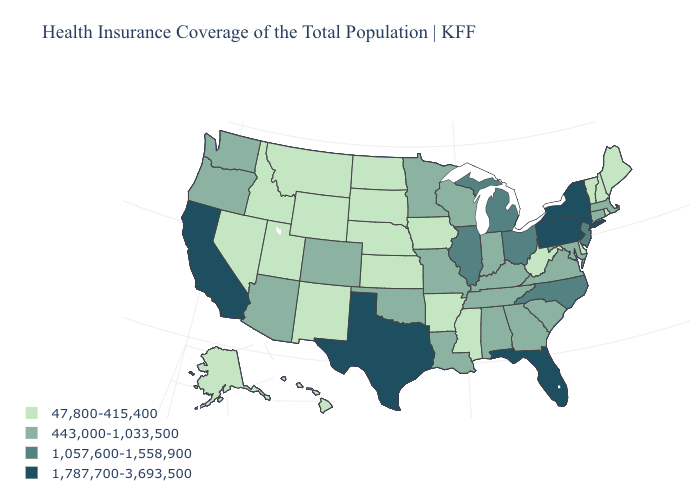Name the states that have a value in the range 443,000-1,033,500?
Short answer required. Alabama, Arizona, Colorado, Connecticut, Georgia, Indiana, Kentucky, Louisiana, Maryland, Massachusetts, Minnesota, Missouri, Oklahoma, Oregon, South Carolina, Tennessee, Virginia, Washington, Wisconsin. Name the states that have a value in the range 1,057,600-1,558,900?
Keep it brief. Illinois, Michigan, New Jersey, North Carolina, Ohio. Name the states that have a value in the range 1,057,600-1,558,900?
Keep it brief. Illinois, Michigan, New Jersey, North Carolina, Ohio. Is the legend a continuous bar?
Give a very brief answer. No. Among the states that border Nebraska , which have the lowest value?
Short answer required. Iowa, Kansas, South Dakota, Wyoming. How many symbols are there in the legend?
Be succinct. 4. Name the states that have a value in the range 1,787,700-3,693,500?
Write a very short answer. California, Florida, New York, Pennsylvania, Texas. Does Michigan have the lowest value in the USA?
Keep it brief. No. How many symbols are there in the legend?
Quick response, please. 4. How many symbols are there in the legend?
Give a very brief answer. 4. Does the map have missing data?
Short answer required. No. Name the states that have a value in the range 47,800-415,400?
Concise answer only. Alaska, Arkansas, Delaware, Hawaii, Idaho, Iowa, Kansas, Maine, Mississippi, Montana, Nebraska, Nevada, New Hampshire, New Mexico, North Dakota, Rhode Island, South Dakota, Utah, Vermont, West Virginia, Wyoming. What is the value of New York?
Short answer required. 1,787,700-3,693,500. Does Hawaii have a lower value than Alaska?
Keep it brief. No. Which states have the lowest value in the South?
Concise answer only. Arkansas, Delaware, Mississippi, West Virginia. 